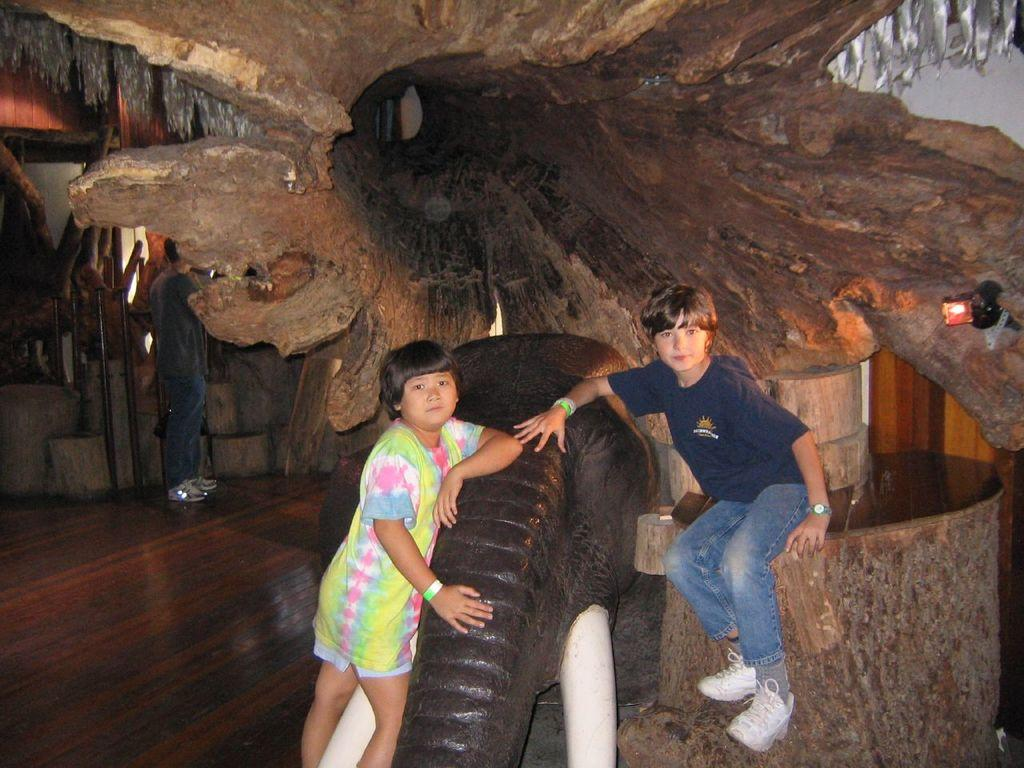How many kids are present in the image? There are two kids in the image. What is one kid doing in the image? One kid is standing beside an elephant. What is the other kid doing in the image? The other kid is sitting on a wooden plank. Can you describe the wooden plank in the background of the image? There is a big wooden plank in the background of the image. What type of marble is being used to play a game in the image? There is no marble or game present in the image; it features two kids and an elephant. 